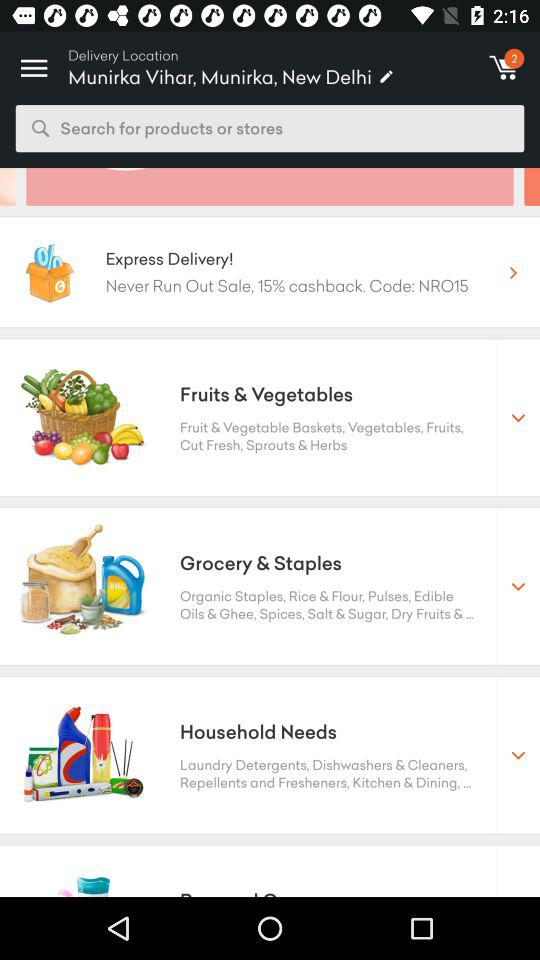What is the code that can be used for the 15% cashback? The code that can be used for the 15% cashback is "NRO15". 